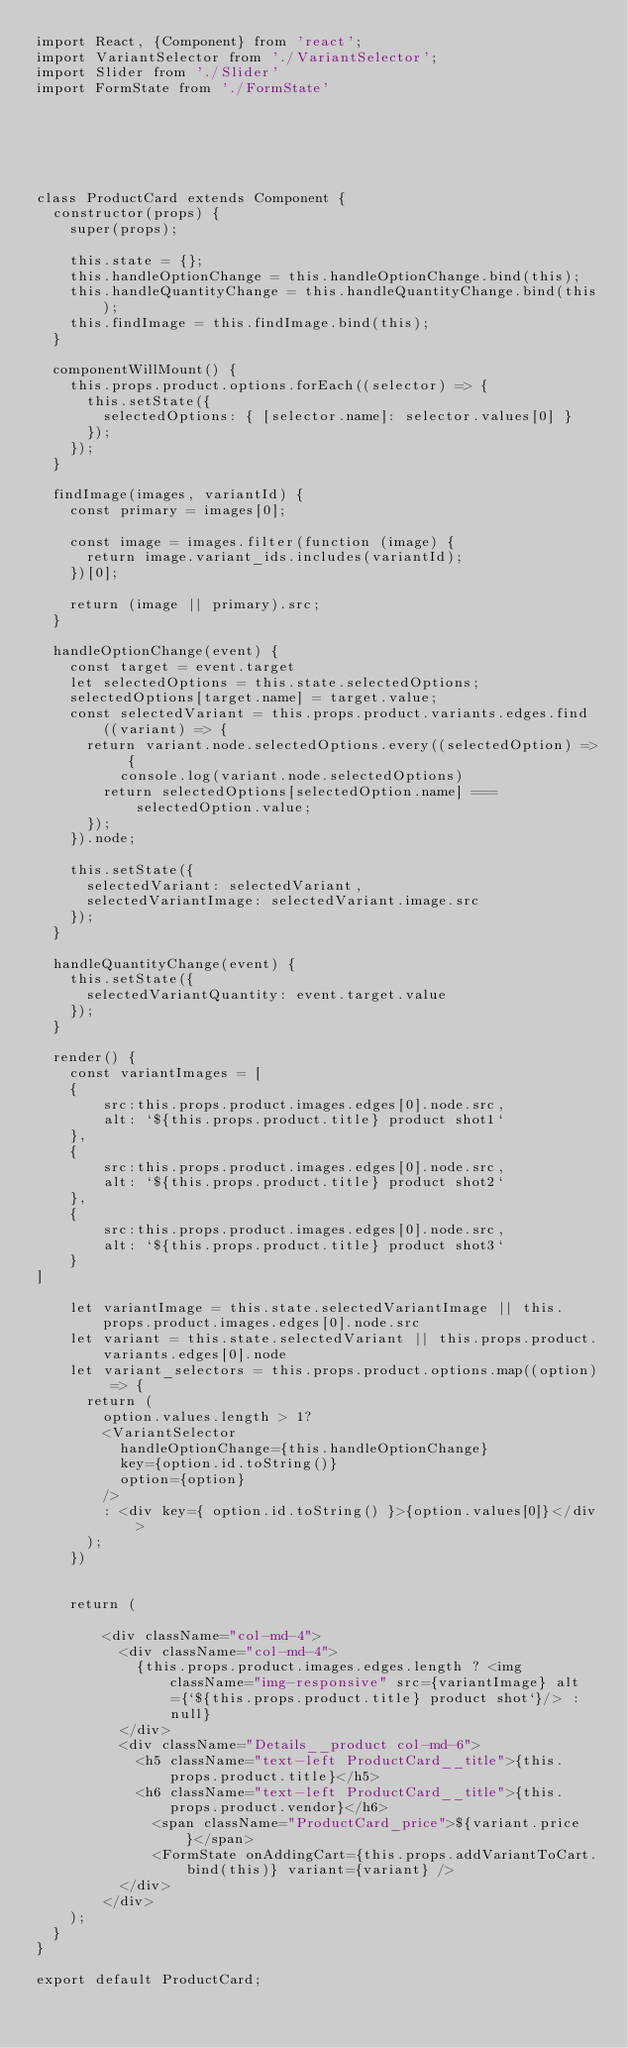Convert code to text. <code><loc_0><loc_0><loc_500><loc_500><_JavaScript_>import React, {Component} from 'react';
import VariantSelector from './VariantSelector';
import Slider from './Slider'
import FormState from './FormState'






class ProductCard extends Component {
  constructor(props) {
    super(props);

    this.state = {};
    this.handleOptionChange = this.handleOptionChange.bind(this);
    this.handleQuantityChange = this.handleQuantityChange.bind(this);
    this.findImage = this.findImage.bind(this);
  }

  componentWillMount() {
    this.props.product.options.forEach((selector) => {
      this.setState({
        selectedOptions: { [selector.name]: selector.values[0] }
      });
    });
  }

  findImage(images, variantId) {
    const primary = images[0];

    const image = images.filter(function (image) {
      return image.variant_ids.includes(variantId);
    })[0];

    return (image || primary).src;
  }

  handleOptionChange(event) {
    const target = event.target
    let selectedOptions = this.state.selectedOptions;
    selectedOptions[target.name] = target.value;
    const selectedVariant = this.props.product.variants.edges.find((variant) => {
      return variant.node.selectedOptions.every((selectedOption) => {
          console.log(variant.node.selectedOptions)
        return selectedOptions[selectedOption.name] === selectedOption.value; 
      });
    }).node;

    this.setState({
      selectedVariant: selectedVariant,
      selectedVariantImage: selectedVariant.image.src
    });
  }

  handleQuantityChange(event) {
    this.setState({
      selectedVariantQuantity: event.target.value
    });
  }

  render() {
    const variantImages = [
    {
        src:this.props.product.images.edges[0].node.src,
        alt: `${this.props.product.title} product shot1`
    },
    {
        src:this.props.product.images.edges[0].node.src,
        alt: `${this.props.product.title} product shot2`
    },
    {
        src:this.props.product.images.edges[0].node.src,
        alt: `${this.props.product.title} product shot3`
    }
]

    let variantImage = this.state.selectedVariantImage || this.props.product.images.edges[0].node.src
    let variant = this.state.selectedVariant || this.props.product.variants.edges[0].node
    let variant_selectors = this.props.product.options.map((option) => {
      return (
        option.values.length > 1?
        <VariantSelector
          handleOptionChange={this.handleOptionChange}
          key={option.id.toString()}
          option={option}
        />
        : <div key={ option.id.toString() }>{option.values[0]}</div>
      );
    })


    return (
      
        <div className="col-md-4">
          <div className="col-md-4">
            {this.props.product.images.edges.length ? <img className="img-responsive" src={variantImage} alt={`${this.props.product.title} product shot`}/> : null}
          </div>
          <div className="Details__product col-md-6">
            <h5 className="text-left ProductCard__title">{this.props.product.title}</h5>
            <h6 className="text-left ProductCard__title">{this.props.product.vendor}</h6>
              <span className="ProductCard_price">${variant.price}</span>
              <FormState onAddingCart={this.props.addVariantToCart.bind(this)} variant={variant} />
          </div>
        </div>
    );
  }
}

export default ProductCard;
</code> 